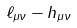<formula> <loc_0><loc_0><loc_500><loc_500>\ell _ { \mu \nu } - h _ { \mu \nu }</formula> 